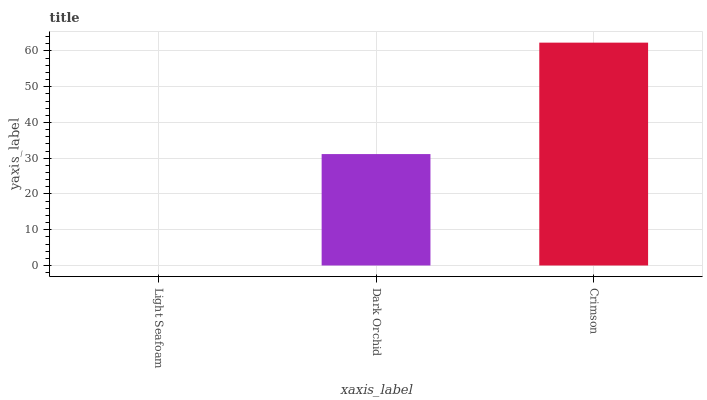Is Dark Orchid the minimum?
Answer yes or no. No. Is Dark Orchid the maximum?
Answer yes or no. No. Is Dark Orchid greater than Light Seafoam?
Answer yes or no. Yes. Is Light Seafoam less than Dark Orchid?
Answer yes or no. Yes. Is Light Seafoam greater than Dark Orchid?
Answer yes or no. No. Is Dark Orchid less than Light Seafoam?
Answer yes or no. No. Is Dark Orchid the high median?
Answer yes or no. Yes. Is Dark Orchid the low median?
Answer yes or no. Yes. Is Light Seafoam the high median?
Answer yes or no. No. Is Crimson the low median?
Answer yes or no. No. 